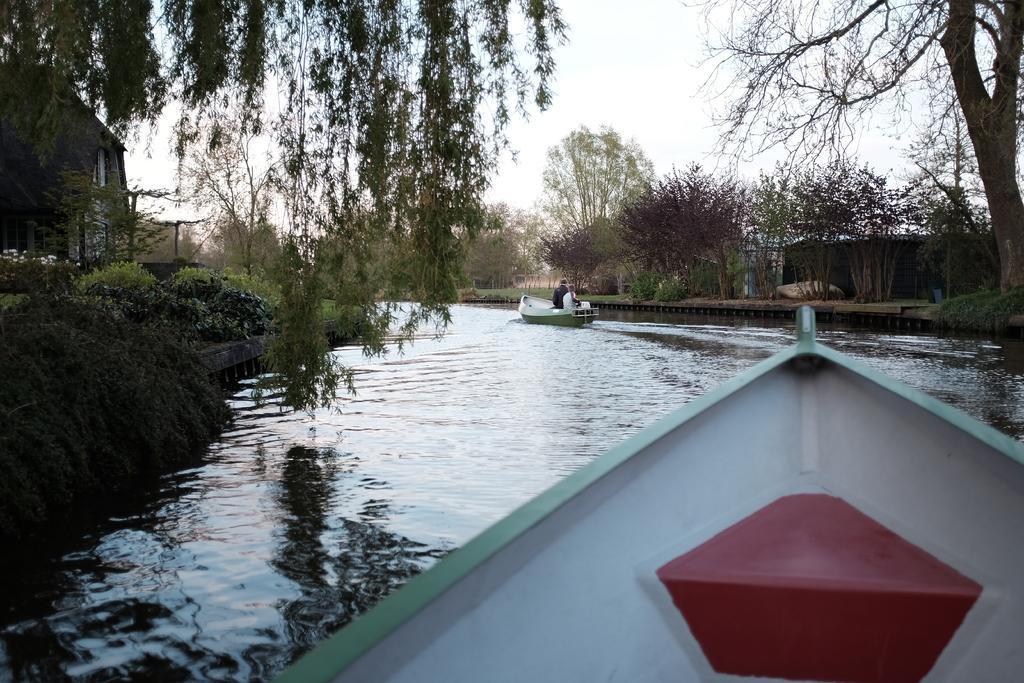In one or two sentences, can you explain what this image depicts? This image is taken outdoors. At the top of the image there is the sky. On the left and right sides of the image there are many trees and plants on the ground and there are two huts. At the bottom of the image there is a boat on the lake. In the middle of the image there is a lake with water and a man is sitting in the boat and sailing on the lake. 